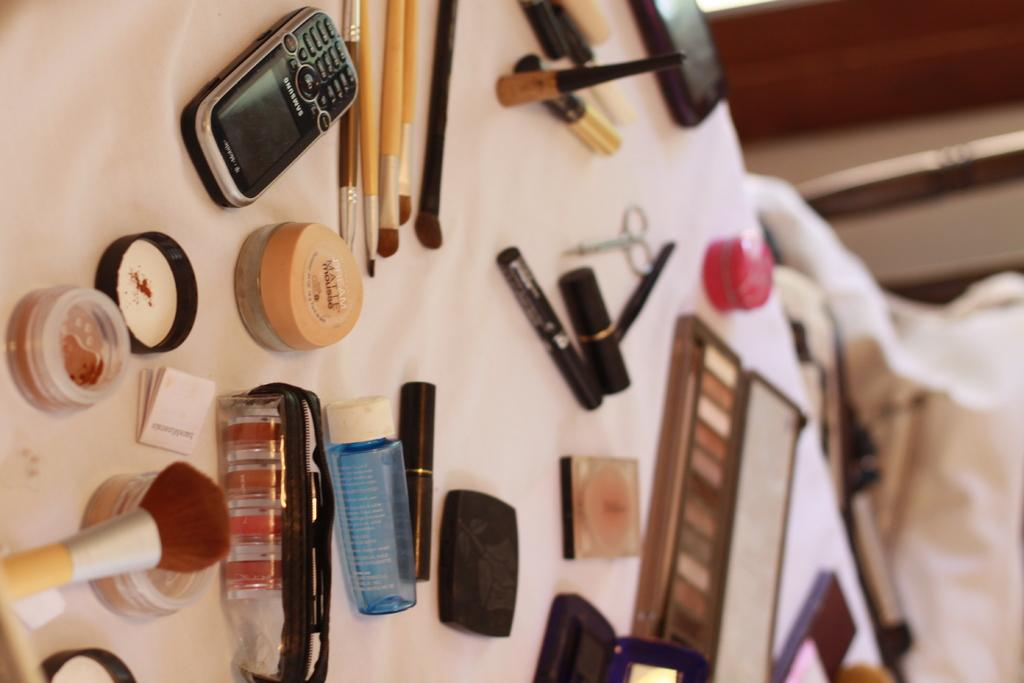<image>
Give a short and clear explanation of the subsequent image. A table is full of makeup, there is a samsung cellphone in the corner. 